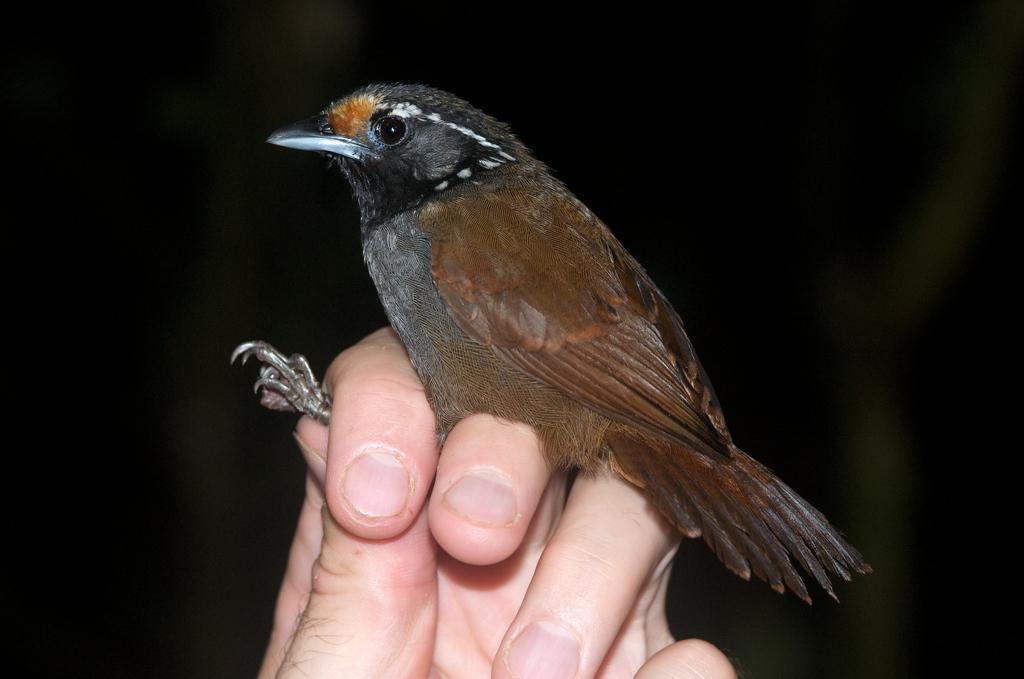What is the main subject of the image? There is a person in the image. What is the person doing in the image? The person is holding a bird in his hand. What type of desk is visible in the image? There is no desk present in the image. Is the person wearing a scarf in the image? The provided facts do not mention a scarf, so it cannot be determined if the person is wearing one. What is the person using to cut the bird in the image? There is no indication in the image that the person is using scissors or any other cutting tool. 